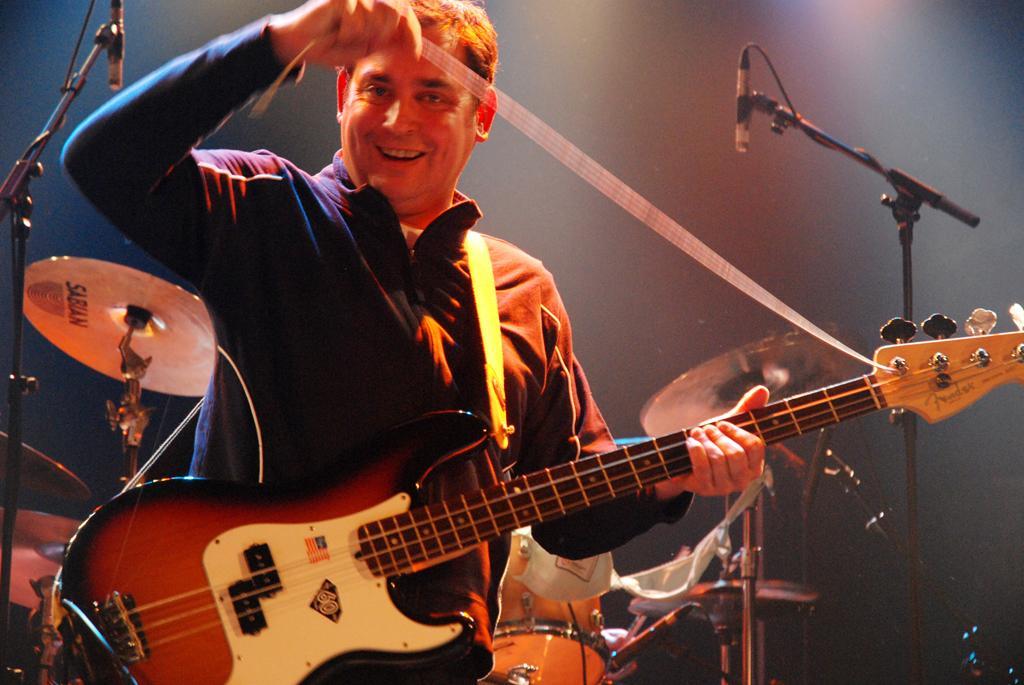Please provide a concise description of this image. In this picture we can see a man is holding a guitar in the front, in the background we can see drums, cymbals and microphones. 